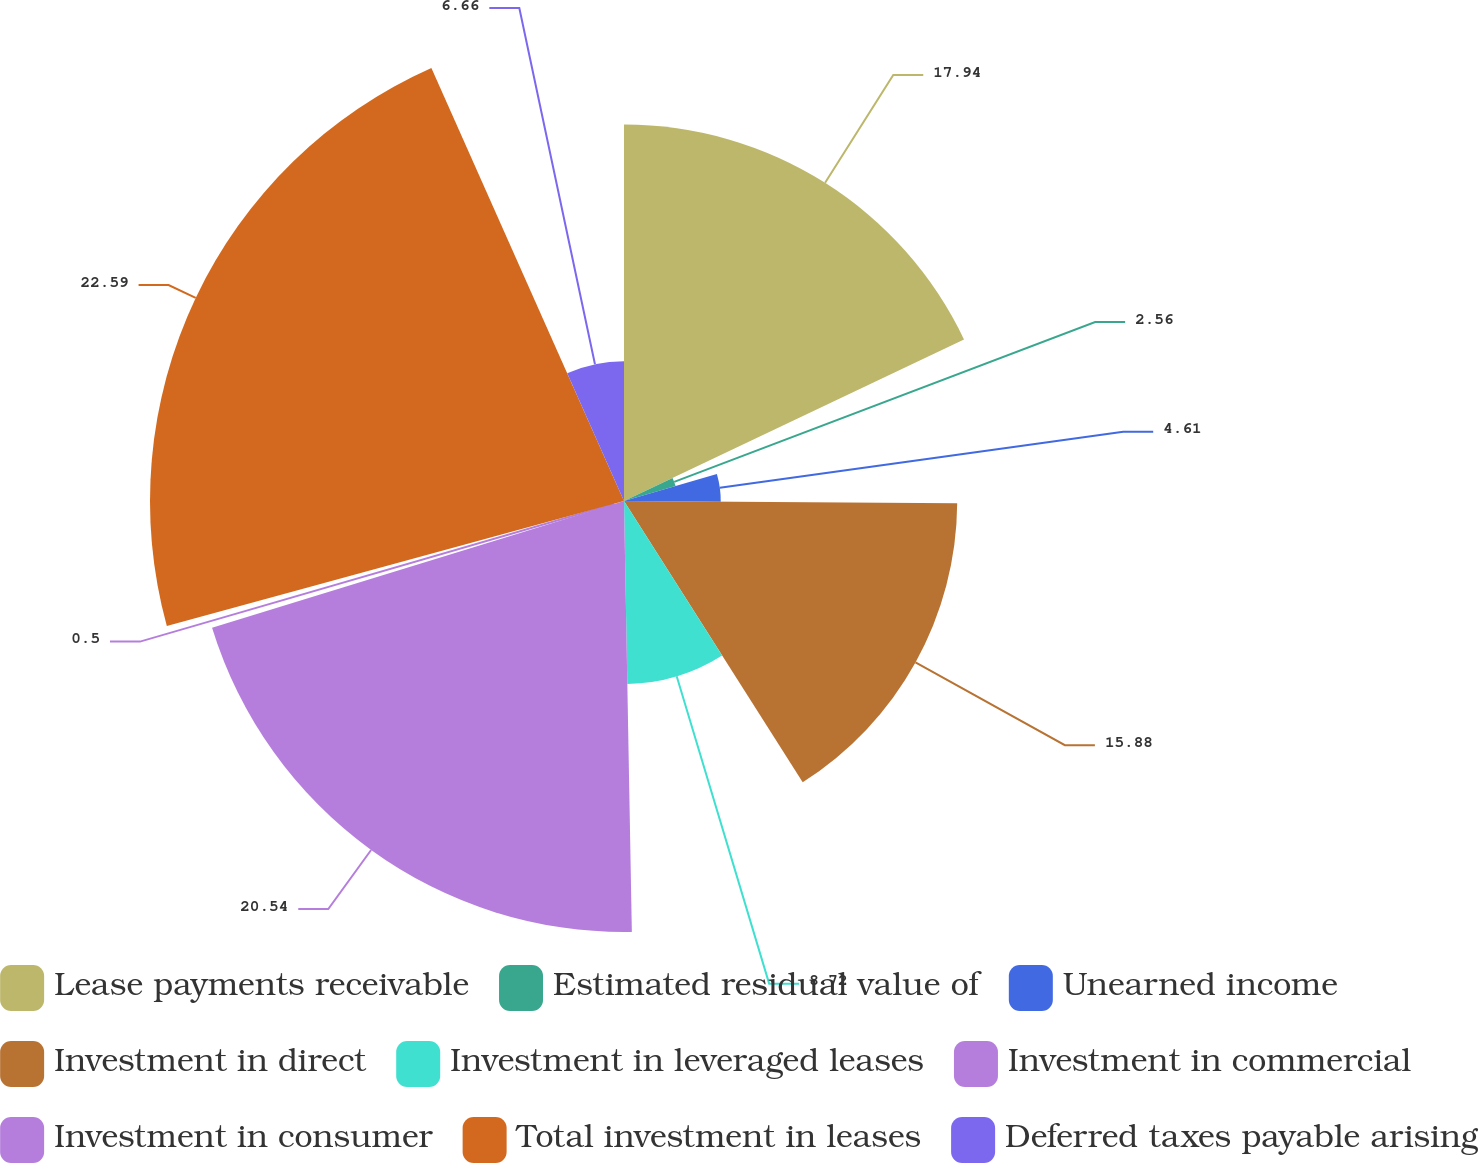Convert chart. <chart><loc_0><loc_0><loc_500><loc_500><pie_chart><fcel>Lease payments receivable<fcel>Estimated residual value of<fcel>Unearned income<fcel>Investment in direct<fcel>Investment in leveraged leases<fcel>Investment in commercial<fcel>Investment in consumer<fcel>Total investment in leases<fcel>Deferred taxes payable arising<nl><fcel>17.94%<fcel>2.56%<fcel>4.61%<fcel>15.88%<fcel>8.72%<fcel>20.54%<fcel>0.5%<fcel>22.59%<fcel>6.66%<nl></chart> 